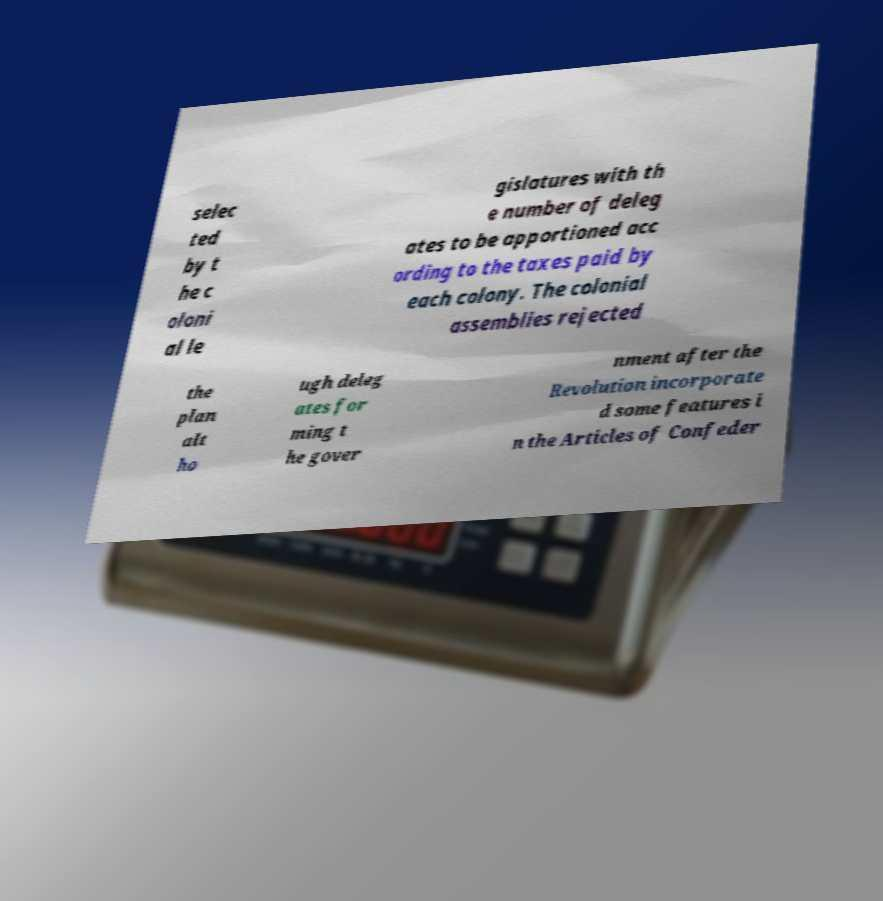Can you accurately transcribe the text from the provided image for me? selec ted by t he c oloni al le gislatures with th e number of deleg ates to be apportioned acc ording to the taxes paid by each colony. The colonial assemblies rejected the plan alt ho ugh deleg ates for ming t he gover nment after the Revolution incorporate d some features i n the Articles of Confeder 